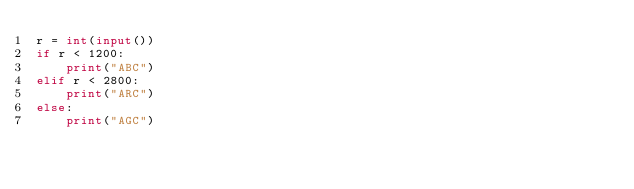<code> <loc_0><loc_0><loc_500><loc_500><_Python_>r = int(input())
if r < 1200:
    print("ABC")
elif r < 2800:
    print("ARC")
else:
    print("AGC")</code> 